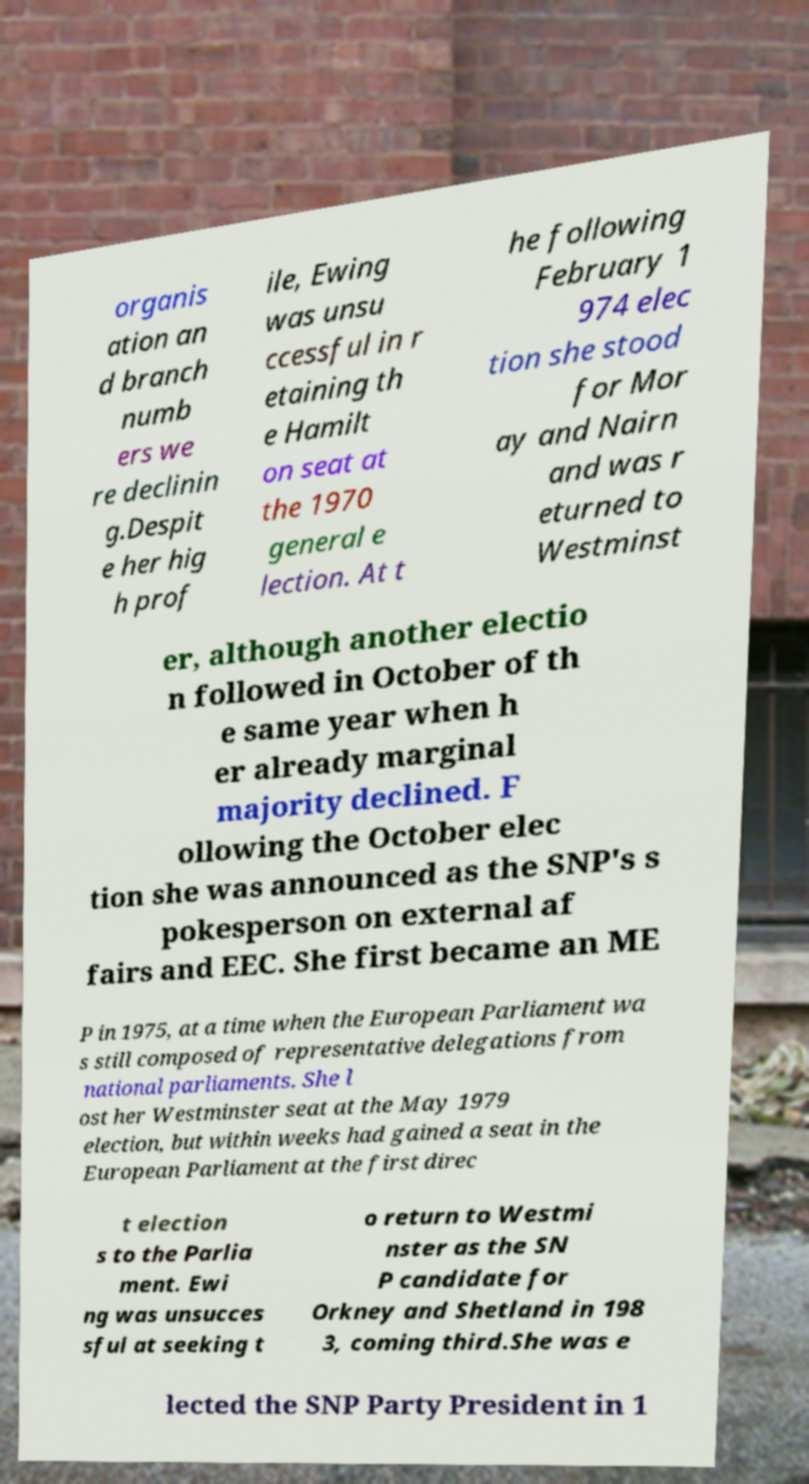Can you accurately transcribe the text from the provided image for me? organis ation an d branch numb ers we re declinin g.Despit e her hig h prof ile, Ewing was unsu ccessful in r etaining th e Hamilt on seat at the 1970 general e lection. At t he following February 1 974 elec tion she stood for Mor ay and Nairn and was r eturned to Westminst er, although another electio n followed in October of th e same year when h er already marginal majority declined. F ollowing the October elec tion she was announced as the SNP's s pokesperson on external af fairs and EEC. She first became an ME P in 1975, at a time when the European Parliament wa s still composed of representative delegations from national parliaments. She l ost her Westminster seat at the May 1979 election, but within weeks had gained a seat in the European Parliament at the first direc t election s to the Parlia ment. Ewi ng was unsucces sful at seeking t o return to Westmi nster as the SN P candidate for Orkney and Shetland in 198 3, coming third.She was e lected the SNP Party President in 1 